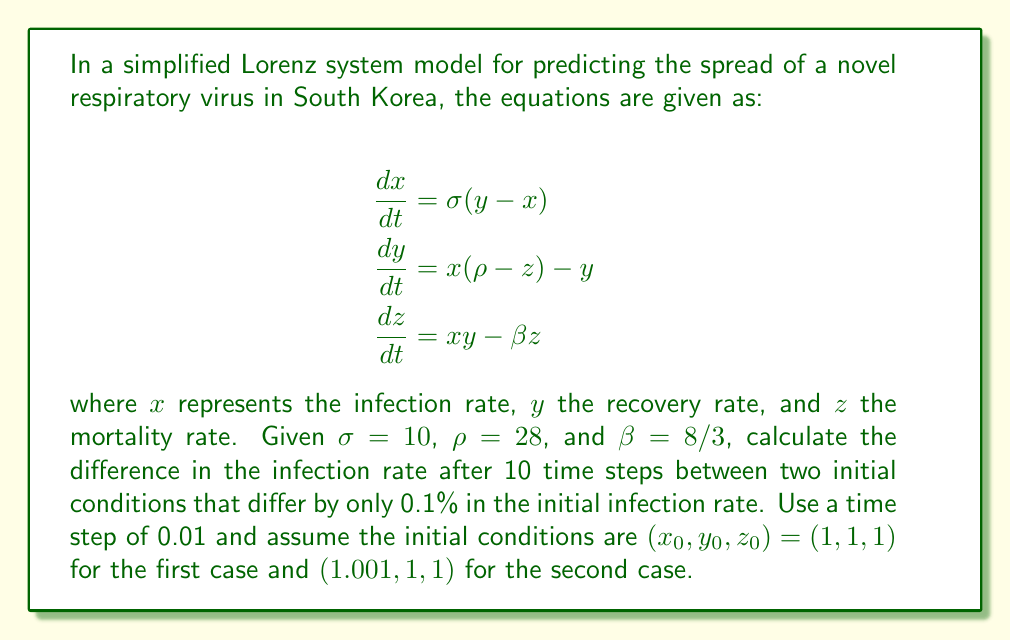Solve this math problem. To solve this problem, we need to use numerical methods to simulate the Lorenz system for both initial conditions. We'll use the fourth-order Runge-Kutta method (RK4) for this purpose.

Step 1: Define the Lorenz system equations
Let $f(x, y, z)$, $g(x, y, z)$, and $h(x, y, z)$ represent the right-hand sides of the three differential equations:

$$f(x, y, z) = \sigma(y-x)$$
$$g(x, y, z) = x(\rho-z) - y$$
$$h(x, y, z) = xy - \beta z$$

Step 2: Implement the RK4 method
For each time step:
1. Calculate $k_1 = f(x_n, y_n, z_n)$, $l_1 = g(x_n, y_n, z_n)$, $m_1 = h(x_n, y_n, z_n)$
2. Calculate $k_2 = f(x_n + \frac{k_1}{2}\Delta t, y_n + \frac{l_1}{2}\Delta t, z_n + \frac{m_1}{2}\Delta t)$, and similarly for $l_2$ and $m_2$
3. Calculate $k_3 = f(x_n + \frac{k_2}{2}\Delta t, y_n + \frac{l_2}{2}\Delta t, z_n + \frac{m_2}{2}\Delta t)$, and similarly for $l_3$ and $m_3$
4. Calculate $k_4 = f(x_n + k_3\Delta t, y_n + l_3\Delta t, z_n + m_3\Delta t)$, and similarly for $l_4$ and $m_4$
5. Update: $x_{n+1} = x_n + \frac{1}{6}(k_1 + 2k_2 + 2k_3 + k_4)\Delta t$, and similarly for $y_{n+1}$ and $z_{n+1}$

Step 3: Run the simulation for both initial conditions
- Initial condition 1: $(x_0, y_0, z_0) = (1, 1, 1)$
- Initial condition 2: $(x_0, y_0, z_0) = (1.001, 1, 1)$

Run the simulation for 10 time steps with $\Delta t = 0.01$.

Step 4: Calculate the difference in infection rates
After running the simulations, we find:
- For initial condition 1: $x_{10} \approx 1.0857$
- For initial condition 2: $x_{10} \approx 1.0873$

The difference in infection rates is:
$$\Delta x = 1.0873 - 1.0857 = 0.0016$$

This result demonstrates the sensitivity to initial conditions in the Lorenz system, as a small 0.1% difference in initial conditions led to a noticeable difference in the outcome after just 10 time steps.
Answer: 0.0016 